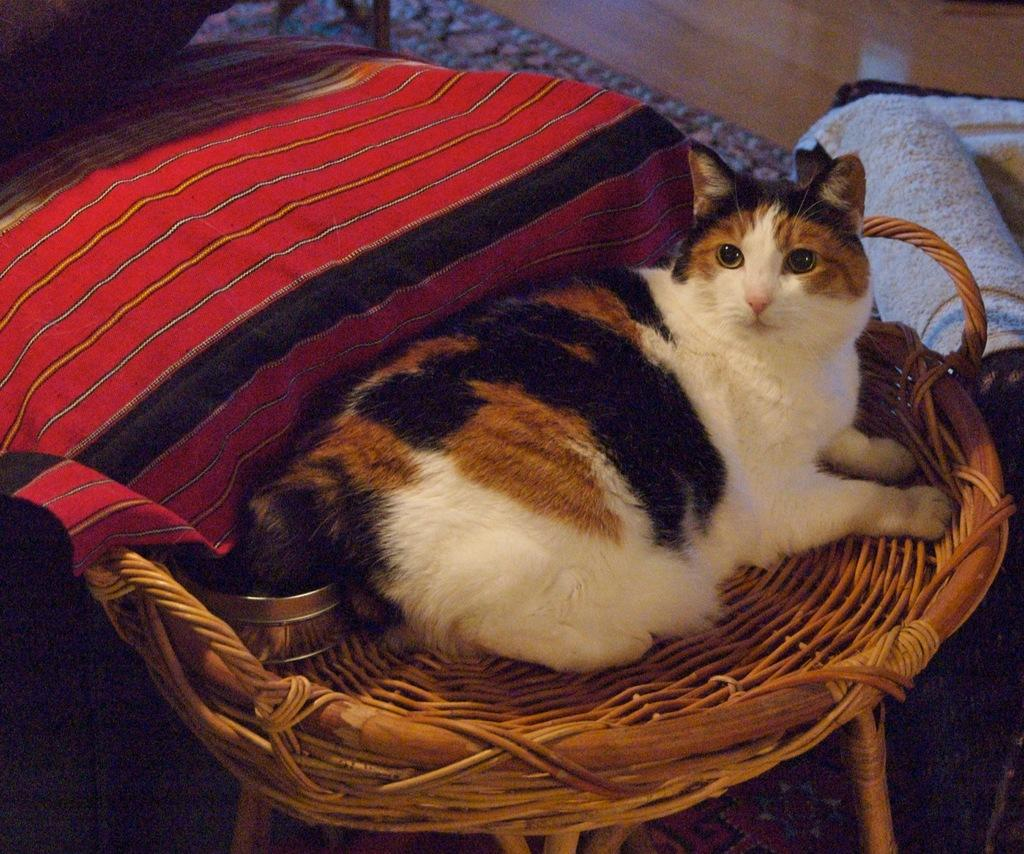What type of animal is in the picture? There is a cat in the picture. What is the cat sitting on? The cat is sitting on a wooden object. What can be seen on the floor in the picture? There are clothes and other objects on the floor. What type of cushion is the cat sitting on? The cat is not sitting on a cushion; it is sitting on a wooden object. What type of butter is visible in the picture? There is no butter present in the picture. 